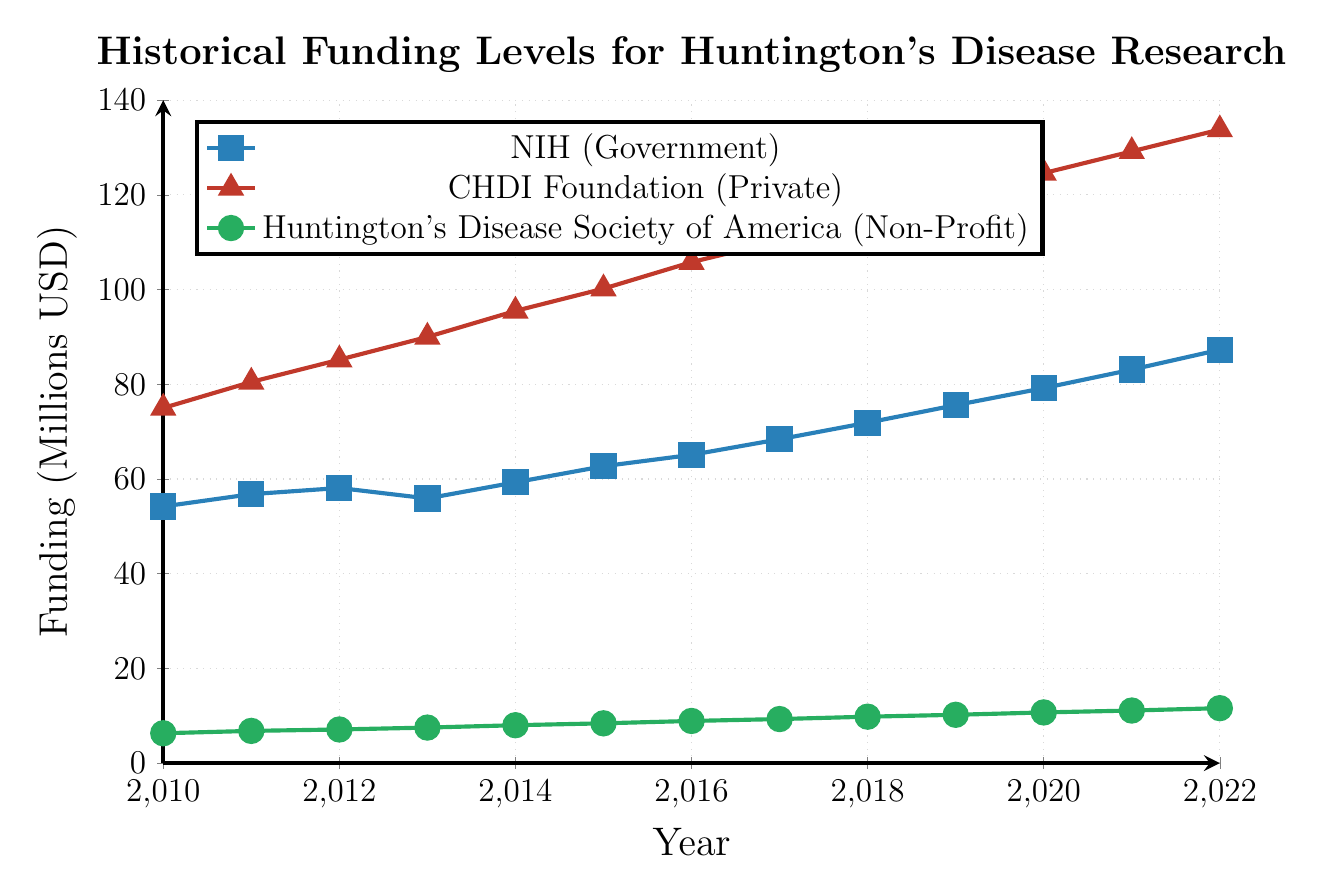Which organization had the highest funding level in 2022? By analyzing the chart, the CHDI Foundation has the highest funding value shown by the line with red markers reaching the top compared to the other lines in 2022.
Answer: CHDI Foundation What is the total funding for Huntington's Disease Society of America (Non-Profit) from 2010 to 2022? To find the total funding, add up the yearly values for the Huntington's Disease Society of America (6.3 + 6.8 + 7.1 + 7.5 + 8.0 + 8.4 + 8.9 + 9.3 + 9.8 + 10.2 + 10.7 + 11.1 + 11.6) = 120.7.
Answer: 120.7 Which year shows the highest funding increase for NIH? To determine the highest funding increase, analyze the differences in the NIH data year-over-year. The difference from 2021 to 2022 is the largest, increasing by 4.2 million (83.1 to 87.3).
Answer: 2022 Compare the funding for CHDI Foundation (Private) and Huntington's Disease Society of America (Non-Profit) in 2015. Which was higher and by how much? Compare the 2015 funding values for CHDI Foundation (100.2) and Huntington's Disease Society of America (8.4). The difference is 91.8 (100.2 - 8.4).
Answer: CHDI Foundation by 91.8 What is the average annual funding by NIH from 2010 to 2022? Calculate the sum of NIH's funding from 2010 to 2022, then divide by the number of years (54.2 + 56.8 + 58.1 + 55.9 + 59.3 + 62.7 + 65.1 + 68.4 + 71.9 + 75.6 + 79.2 + 83.1 + 87.3) / 13 = 66.7.
Answer: 66.7 Which organization had the smallest funding increase from 2010 to 2022? Analyze the overall increase for each organization from 2010 to 2022. NIH: 87.3 - 54.2 = 33.1, CHDI: 133.8 - 75.0 = 58.8, HDSA: 11.6 - 6.3 = 5.3. The Huntington's Disease Society of America had the smallest increase.
Answer: Huntington's Disease Society of America In which years did NIH funding decrease compared to the previous year? Compare NIH funding year-by-year and identify years with a decrease. Funding decreased in 2013 compared to 2012 (58.1 to 55.9).
Answer: 2013 What is the difference in funding between the CHDI Foundation and the NIH in 2020? In 2020, compare the funding levels of CHDI Foundation (124.6) and NIH (79.2). The difference is 45.4 (124.6 - 79.2).
Answer: 45.4 Which line represents the Huntington's Disease Society of America and what color is it in the figure? Based on the legend, the line representing the Huntington's Disease Society of America is green with circle markers.
Answer: Green with circle markers 